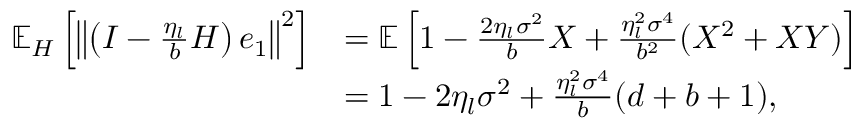Convert formula to latex. <formula><loc_0><loc_0><loc_500><loc_500>\begin{array} { r l } { \mathbb { E } _ { H } \left [ \left \| \left ( I - \frac { \eta _ { l } } { b } H \right ) e _ { 1 } \right \| ^ { 2 } \right ] } & { = \mathbb { E } \left [ 1 - \frac { 2 \eta _ { l } \sigma ^ { 2 } } { b } X + \frac { \eta _ { l } ^ { 2 } \sigma ^ { 4 } } { b ^ { 2 } } ( X ^ { 2 } + X Y ) \right ] } \\ & { = 1 - 2 \eta _ { l } \sigma ^ { 2 } + \frac { \eta _ { l } ^ { 2 } \sigma ^ { 4 } } { b } ( d + b + 1 ) , } \end{array}</formula> 